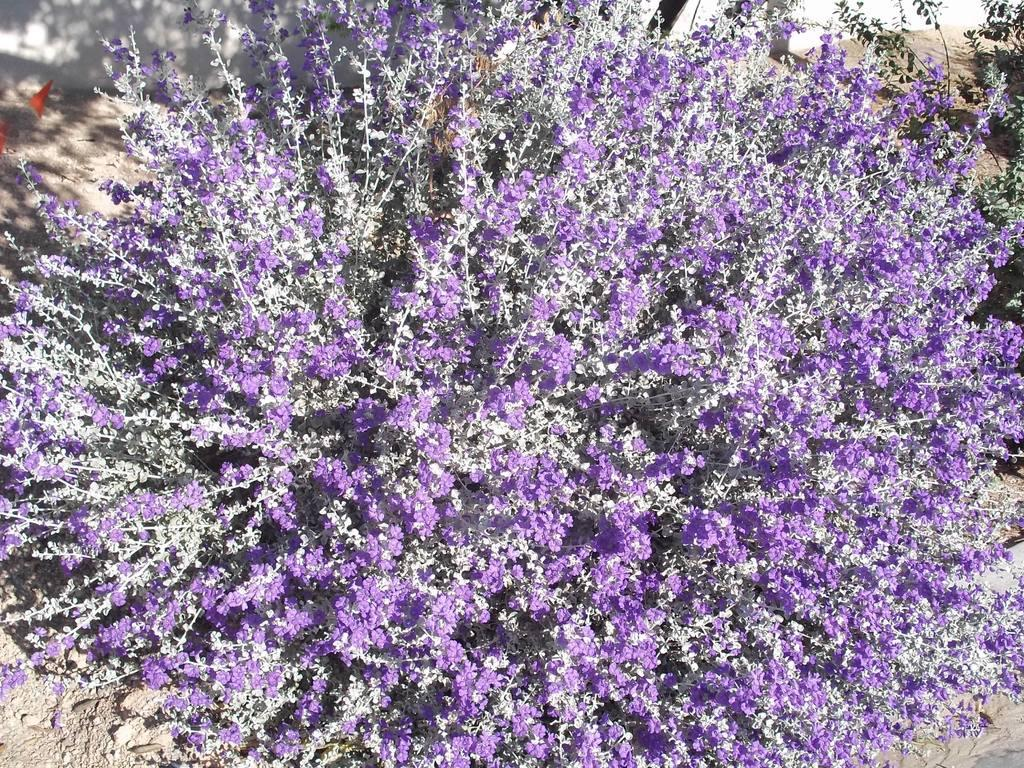What type of living organisms can be seen in the image? Plants and flowers are visible in the image. What color is the wall in the background of the image? The wall in the background of the image is white. What type of activity is the insect performing in the image? There is no insect present in the image, so no such activity can be observed. 